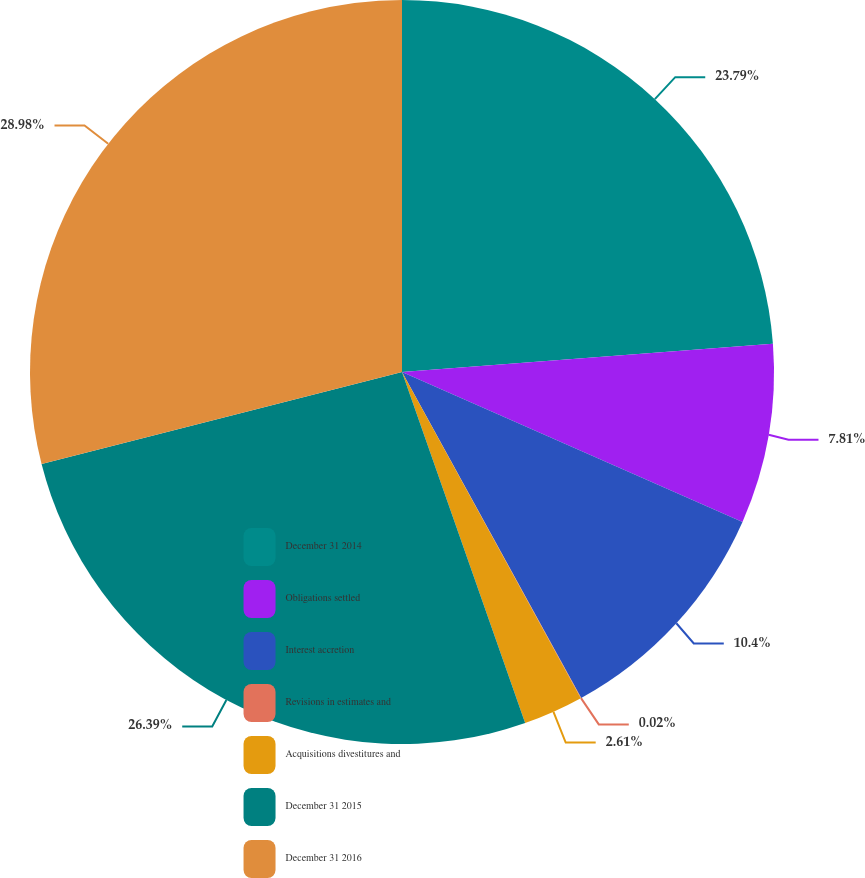Convert chart to OTSL. <chart><loc_0><loc_0><loc_500><loc_500><pie_chart><fcel>December 31 2014<fcel>Obligations settled<fcel>Interest accretion<fcel>Revisions in estimates and<fcel>Acquisitions divestitures and<fcel>December 31 2015<fcel>December 31 2016<nl><fcel>23.79%<fcel>7.81%<fcel>10.4%<fcel>0.02%<fcel>2.61%<fcel>26.39%<fcel>28.98%<nl></chart> 